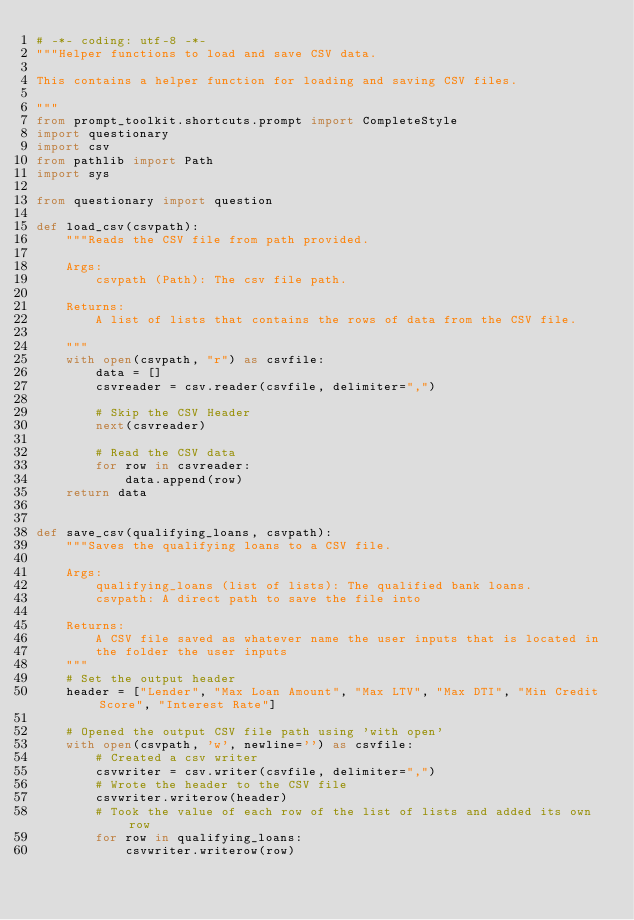Convert code to text. <code><loc_0><loc_0><loc_500><loc_500><_Python_># -*- coding: utf-8 -*-
"""Helper functions to load and save CSV data.

This contains a helper function for loading and saving CSV files.

"""
from prompt_toolkit.shortcuts.prompt import CompleteStyle
import questionary
import csv
from pathlib import Path
import sys

from questionary import question

def load_csv(csvpath):
    """Reads the CSV file from path provided.

    Args:
        csvpath (Path): The csv file path.

    Returns:
        A list of lists that contains the rows of data from the CSV file.

    """
    with open(csvpath, "r") as csvfile:
        data = []
        csvreader = csv.reader(csvfile, delimiter=",")

        # Skip the CSV Header
        next(csvreader)

        # Read the CSV data
        for row in csvreader:
            data.append(row)
    return data


def save_csv(qualifying_loans, csvpath):
    """Saves the qualifying loans to a CSV file. 
    
    Args:
        qualifying_loans (list of lists): The qualified bank loans.
        csvpath: A direct path to save the file into 
        
    Returns:
        A CSV file saved as whatever name the user inputs that is located in
        the folder the user inputs
    """
    # Set the output header
    header = ["Lender", "Max Loan Amount", "Max LTV", "Max DTI", "Min Credit Score", "Interest Rate"]
    
    # Opened the output CSV file path using 'with open'
    with open(csvpath, 'w', newline='') as csvfile:
        # Created a csv writer
        csvwriter = csv.writer(csvfile, delimiter=",")
        # Wrote the header to the CSV file
        csvwriter.writerow(header)
        # Took the value of each row of the list of lists and added its own row
        for row in qualifying_loans:
            csvwriter.writerow(row)
    
    </code> 